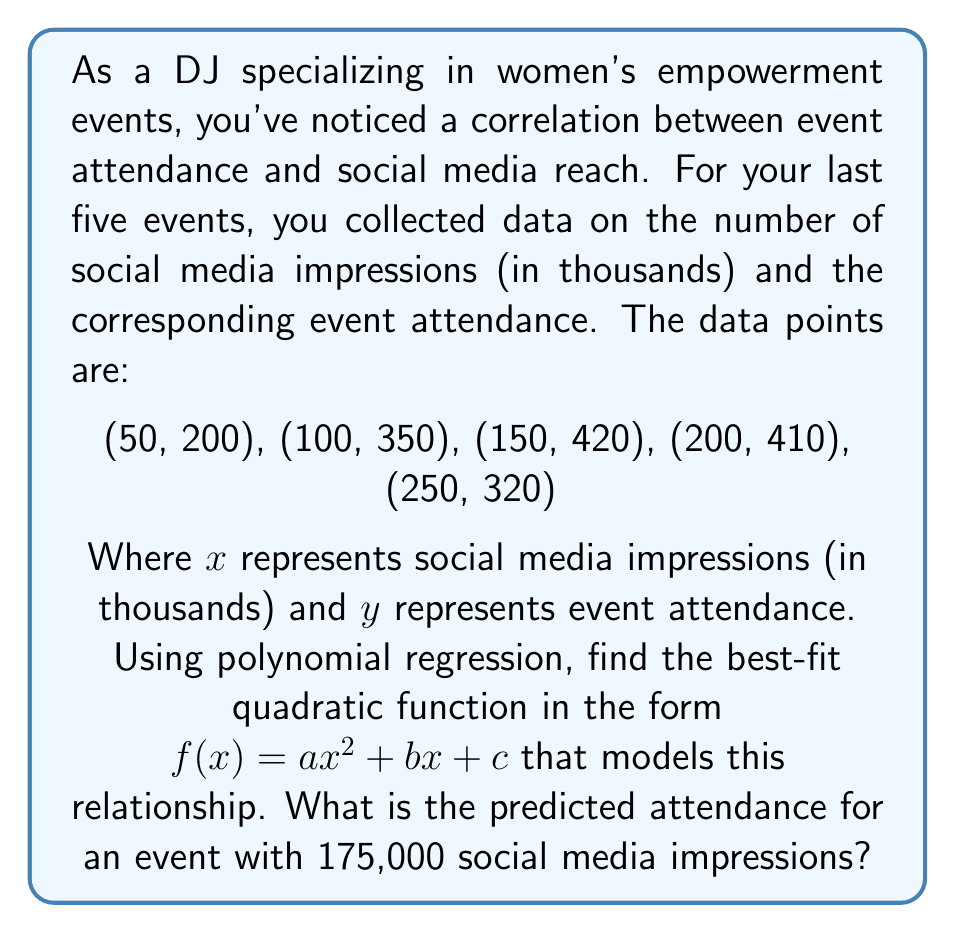What is the answer to this math problem? To find the best-fit quadratic function using polynomial regression, we'll follow these steps:

1. Set up the system of normal equations:
   $$\begin{cases}
   \sum y = an\sum x^2 + b\sum x + cn \\
   \sum xy = a\sum x^3 + b\sum x^2 + c\sum x \\
   \sum x^2y = a\sum x^4 + b\sum x^3 + c\sum x^2
   \end{cases}$$

2. Calculate the required sums:
   $n = 5$
   $\sum x = 750$
   $\sum y = 1700$
   $\sum x^2 = 137,500$
   $\sum x^3 = 28,750,000$
   $\sum x^4 = 6,562,500,000$
   $\sum xy = 272,500$
   $\sum x^2y = 53,575,000$

3. Substitute these values into the normal equations:
   $$\begin{cases}
   1700 = 137,500a + 750b + 5c \\
   272,500 = 28,750,000a + 137,500b + 750c \\
   53,575,000 = 6,562,500,000a + 28,750,000b + 137,500c
   \end{cases}$$

4. Solve this system of equations using a method like Gaussian elimination or matrix operations. The solution is:
   $a \approx -0.0056$
   $b \approx 2.24$
   $c \approx 91.6$

5. Therefore, the best-fit quadratic function is:
   $f(x) = -0.0056x^2 + 2.24x + 91.6$

6. To predict the attendance for an event with 175,000 social media impressions, substitute $x = 175$ into the function:
   $f(175) = -0.0056(175)^2 + 2.24(175) + 91.6$
   $= -171.5 + 392 + 91.6$
   $\approx 312.1$
Answer: The best-fit quadratic function is $f(x) = -0.0056x^2 + 2.24x + 91.6$, and the predicted attendance for an event with 175,000 social media impressions is approximately 312 people. 